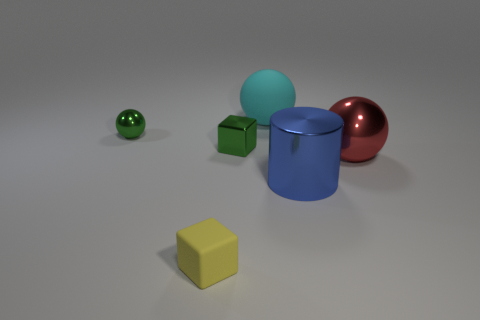Add 1 small yellow objects. How many objects exist? 7 Subtract all cylinders. How many objects are left? 5 Add 6 tiny yellow metallic balls. How many tiny yellow metallic balls exist? 6 Subtract 0 cyan cubes. How many objects are left? 6 Subtract all big yellow rubber cubes. Subtract all small cubes. How many objects are left? 4 Add 5 green shiny balls. How many green shiny balls are left? 6 